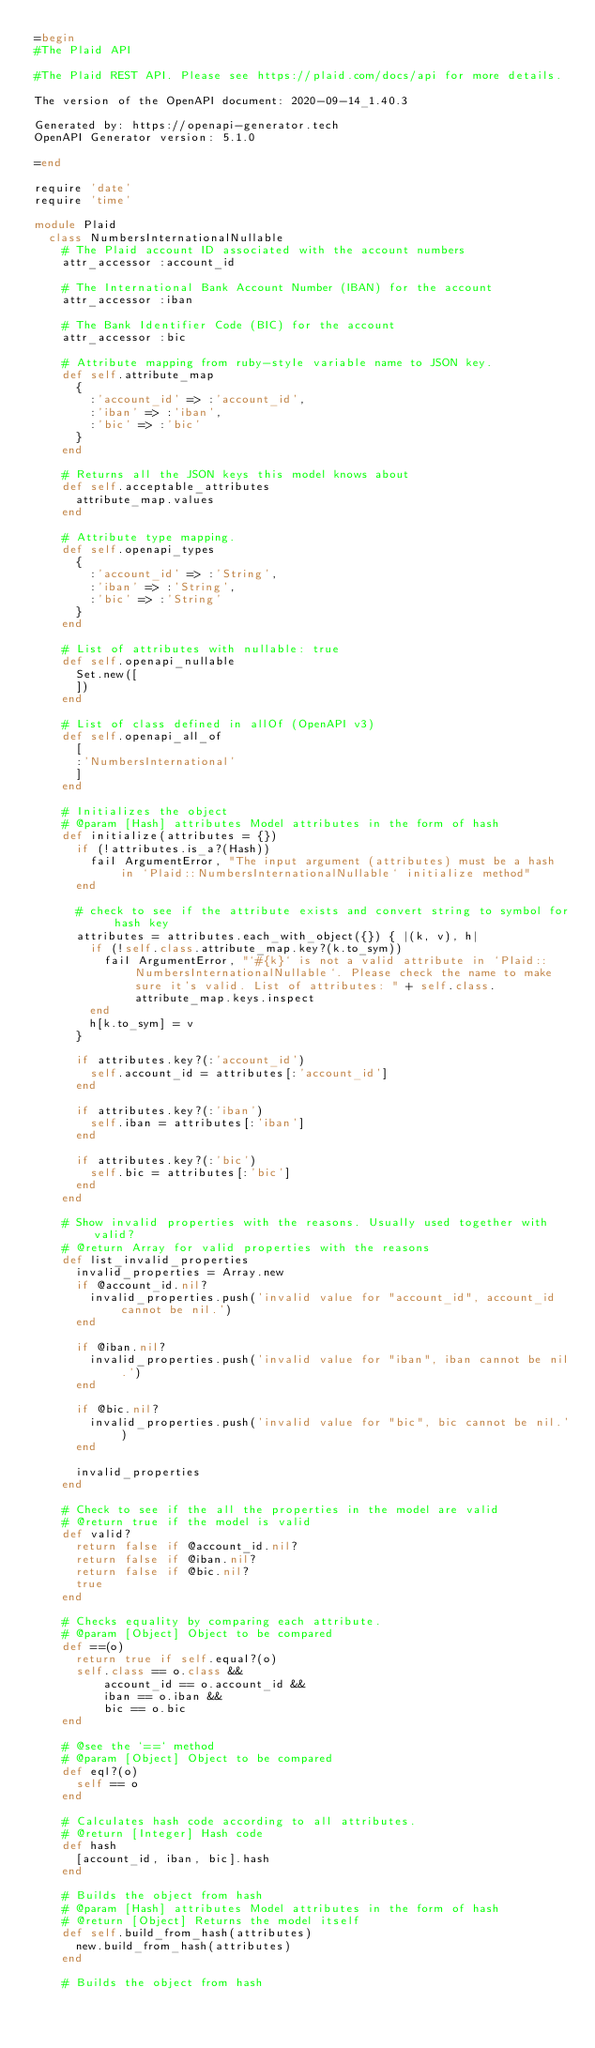Convert code to text. <code><loc_0><loc_0><loc_500><loc_500><_Ruby_>=begin
#The Plaid API

#The Plaid REST API. Please see https://plaid.com/docs/api for more details.

The version of the OpenAPI document: 2020-09-14_1.40.3

Generated by: https://openapi-generator.tech
OpenAPI Generator version: 5.1.0

=end

require 'date'
require 'time'

module Plaid
  class NumbersInternationalNullable
    # The Plaid account ID associated with the account numbers
    attr_accessor :account_id

    # The International Bank Account Number (IBAN) for the account
    attr_accessor :iban

    # The Bank Identifier Code (BIC) for the account
    attr_accessor :bic

    # Attribute mapping from ruby-style variable name to JSON key.
    def self.attribute_map
      {
        :'account_id' => :'account_id',
        :'iban' => :'iban',
        :'bic' => :'bic'
      }
    end

    # Returns all the JSON keys this model knows about
    def self.acceptable_attributes
      attribute_map.values
    end

    # Attribute type mapping.
    def self.openapi_types
      {
        :'account_id' => :'String',
        :'iban' => :'String',
        :'bic' => :'String'
      }
    end

    # List of attributes with nullable: true
    def self.openapi_nullable
      Set.new([
      ])
    end

    # List of class defined in allOf (OpenAPI v3)
    def self.openapi_all_of
      [
      :'NumbersInternational'
      ]
    end

    # Initializes the object
    # @param [Hash] attributes Model attributes in the form of hash
    def initialize(attributes = {})
      if (!attributes.is_a?(Hash))
        fail ArgumentError, "The input argument (attributes) must be a hash in `Plaid::NumbersInternationalNullable` initialize method"
      end

      # check to see if the attribute exists and convert string to symbol for hash key
      attributes = attributes.each_with_object({}) { |(k, v), h|
        if (!self.class.attribute_map.key?(k.to_sym))
          fail ArgumentError, "`#{k}` is not a valid attribute in `Plaid::NumbersInternationalNullable`. Please check the name to make sure it's valid. List of attributes: " + self.class.attribute_map.keys.inspect
        end
        h[k.to_sym] = v
      }

      if attributes.key?(:'account_id')
        self.account_id = attributes[:'account_id']
      end

      if attributes.key?(:'iban')
        self.iban = attributes[:'iban']
      end

      if attributes.key?(:'bic')
        self.bic = attributes[:'bic']
      end
    end

    # Show invalid properties with the reasons. Usually used together with valid?
    # @return Array for valid properties with the reasons
    def list_invalid_properties
      invalid_properties = Array.new
      if @account_id.nil?
        invalid_properties.push('invalid value for "account_id", account_id cannot be nil.')
      end

      if @iban.nil?
        invalid_properties.push('invalid value for "iban", iban cannot be nil.')
      end

      if @bic.nil?
        invalid_properties.push('invalid value for "bic", bic cannot be nil.')
      end

      invalid_properties
    end

    # Check to see if the all the properties in the model are valid
    # @return true if the model is valid
    def valid?
      return false if @account_id.nil?
      return false if @iban.nil?
      return false if @bic.nil?
      true
    end

    # Checks equality by comparing each attribute.
    # @param [Object] Object to be compared
    def ==(o)
      return true if self.equal?(o)
      self.class == o.class &&
          account_id == o.account_id &&
          iban == o.iban &&
          bic == o.bic
    end

    # @see the `==` method
    # @param [Object] Object to be compared
    def eql?(o)
      self == o
    end

    # Calculates hash code according to all attributes.
    # @return [Integer] Hash code
    def hash
      [account_id, iban, bic].hash
    end

    # Builds the object from hash
    # @param [Hash] attributes Model attributes in the form of hash
    # @return [Object] Returns the model itself
    def self.build_from_hash(attributes)
      new.build_from_hash(attributes)
    end

    # Builds the object from hash</code> 